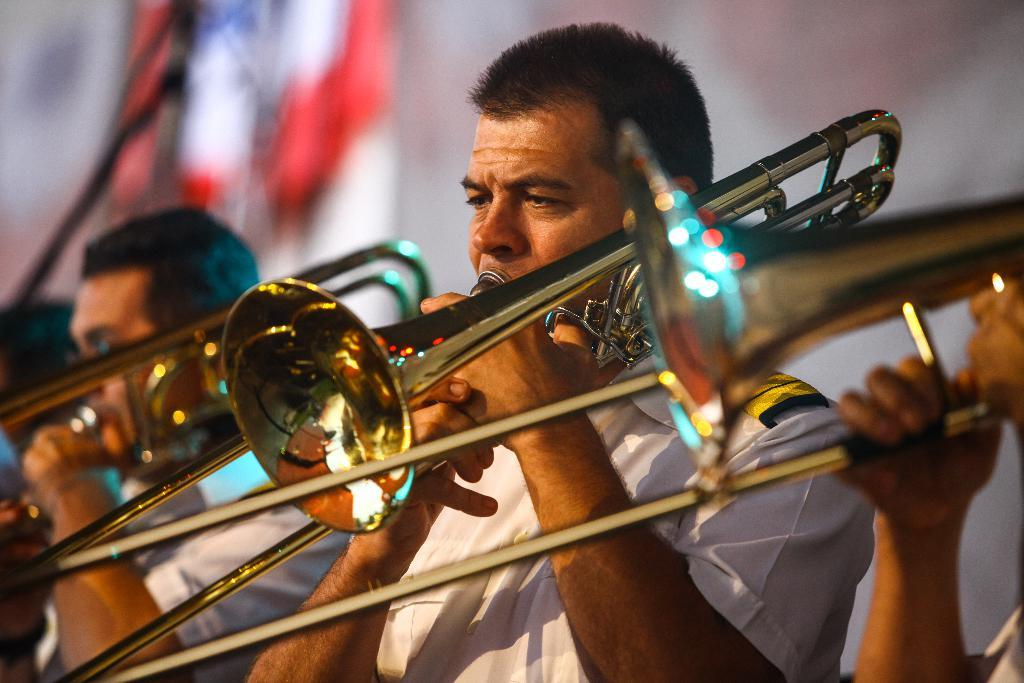How many people are in the image? There are three persons in the image. What are the persons doing in the image? The persons are playing trombones. Can you describe the background of the image? The background of the image is blurred. How many cows can be seen grazing in the background of the image? There are no cows present in the image; the background is blurred. What type of mouthpiece is used for the trombones in the image? The provided facts do not mention the type of mouthpiece used for the trombones in the image. 